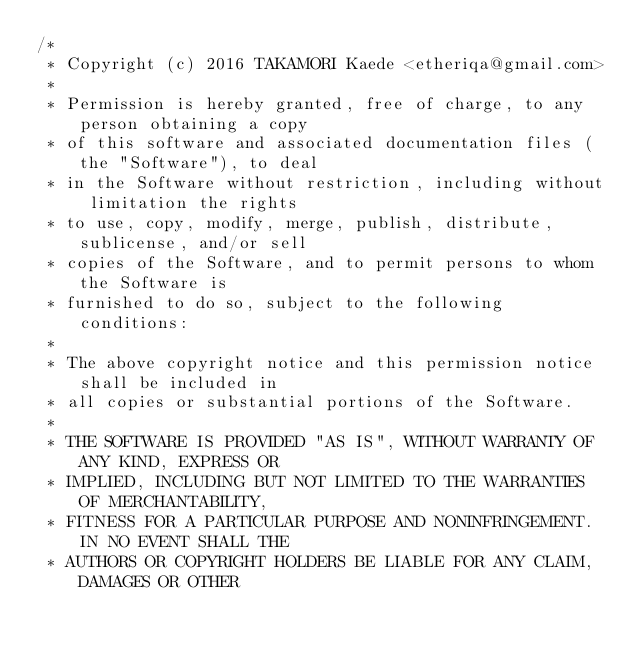Convert code to text. <code><loc_0><loc_0><loc_500><loc_500><_C_>/*
 * Copyright (c) 2016 TAKAMORI Kaede <etheriqa@gmail.com>
 *
 * Permission is hereby granted, free of charge, to any person obtaining a copy
 * of this software and associated documentation files (the "Software"), to deal
 * in the Software without restriction, including without limitation the rights
 * to use, copy, modify, merge, publish, distribute, sublicense, and/or sell
 * copies of the Software, and to permit persons to whom the Software is
 * furnished to do so, subject to the following conditions:
 *
 * The above copyright notice and this permission notice shall be included in
 * all copies or substantial portions of the Software.
 *
 * THE SOFTWARE IS PROVIDED "AS IS", WITHOUT WARRANTY OF ANY KIND, EXPRESS OR
 * IMPLIED, INCLUDING BUT NOT LIMITED TO THE WARRANTIES OF MERCHANTABILITY,
 * FITNESS FOR A PARTICULAR PURPOSE AND NONINFRINGEMENT. IN NO EVENT SHALL THE
 * AUTHORS OR COPYRIGHT HOLDERS BE LIABLE FOR ANY CLAIM, DAMAGES OR OTHER</code> 